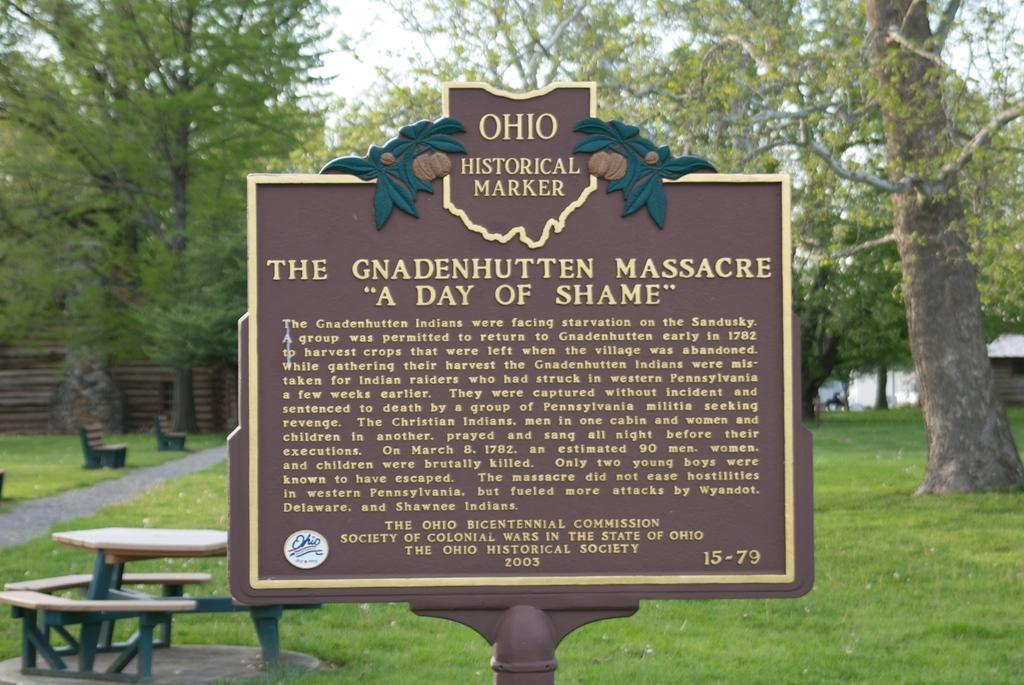Please provide a concise description of this image. In this image we can see a sign board. In the background, we can see a table, benches, grassy land, trees and the sky. 